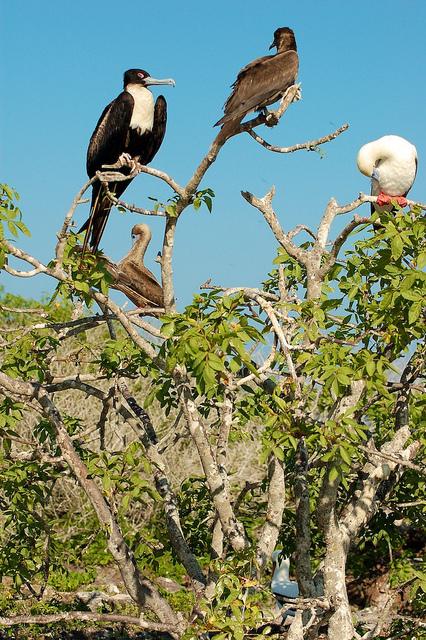What types of birds are these?
Write a very short answer. Pelicans. What type of tree is in the picture?
Short answer required. Leafy. How many birds are in the trees?
Answer briefly. 3. What sort of bird is on the left?
Answer briefly. Pelican. Is it night time?
Be succinct. No. 